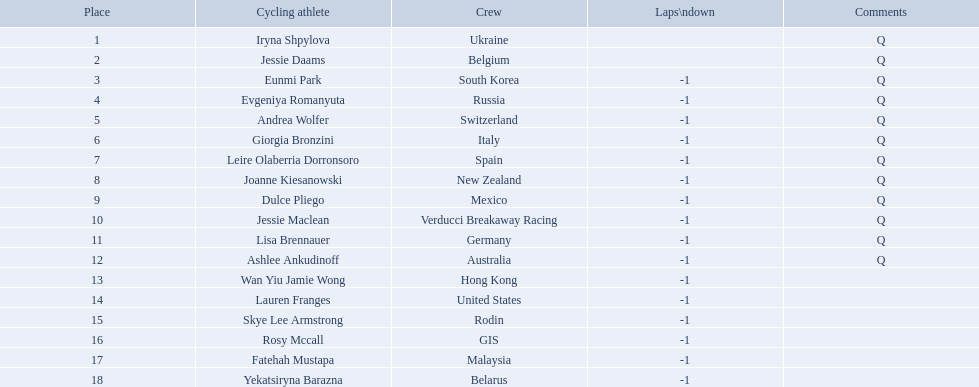Who are all of the cyclists in this race? Iryna Shpylova, Jessie Daams, Eunmi Park, Evgeniya Romanyuta, Andrea Wolfer, Giorgia Bronzini, Leire Olaberria Dorronsoro, Joanne Kiesanowski, Dulce Pliego, Jessie Maclean, Lisa Brennauer, Ashlee Ankudinoff, Wan Yiu Jamie Wong, Lauren Franges, Skye Lee Armstrong, Rosy Mccall, Fatehah Mustapa, Yekatsiryna Barazna. Of these, which one has the lowest numbered rank? Iryna Shpylova. Who competed in the race? Iryna Shpylova, Jessie Daams, Eunmi Park, Evgeniya Romanyuta, Andrea Wolfer, Giorgia Bronzini, Leire Olaberria Dorronsoro, Joanne Kiesanowski, Dulce Pliego, Jessie Maclean, Lisa Brennauer, Ashlee Ankudinoff, Wan Yiu Jamie Wong, Lauren Franges, Skye Lee Armstrong, Rosy Mccall, Fatehah Mustapa, Yekatsiryna Barazna. Who ranked highest in the race? Iryna Shpylova. 